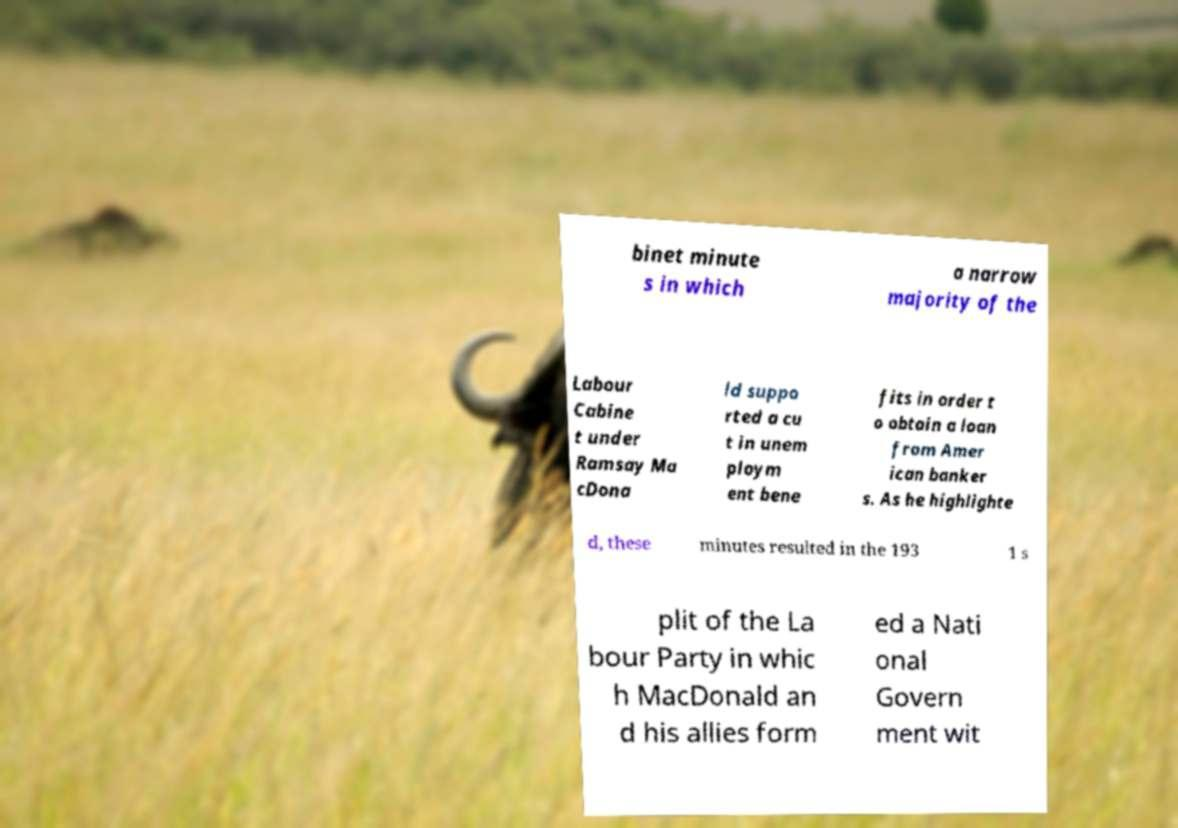Can you accurately transcribe the text from the provided image for me? binet minute s in which a narrow majority of the Labour Cabine t under Ramsay Ma cDona ld suppo rted a cu t in unem ploym ent bene fits in order t o obtain a loan from Amer ican banker s. As he highlighte d, these minutes resulted in the 193 1 s plit of the La bour Party in whic h MacDonald an d his allies form ed a Nati onal Govern ment wit 